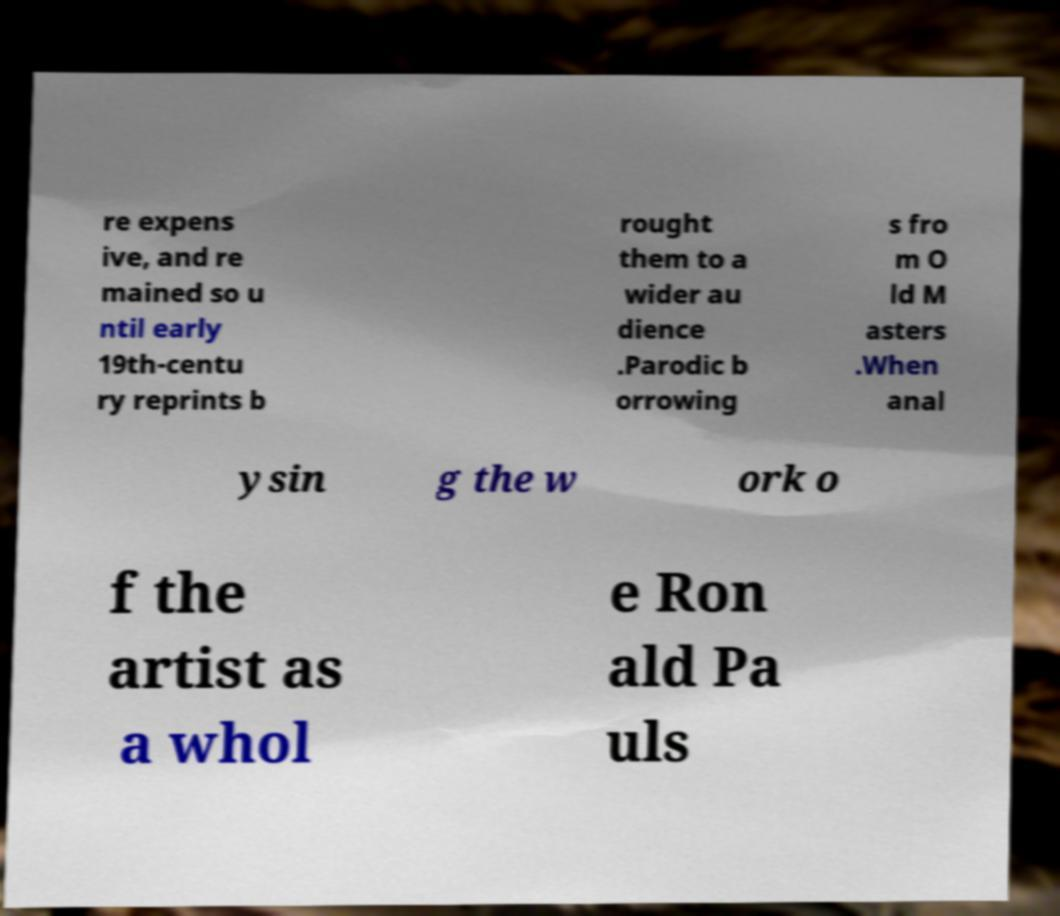What messages or text are displayed in this image? I need them in a readable, typed format. re expens ive, and re mained so u ntil early 19th-centu ry reprints b rought them to a wider au dience .Parodic b orrowing s fro m O ld M asters .When anal ysin g the w ork o f the artist as a whol e Ron ald Pa uls 